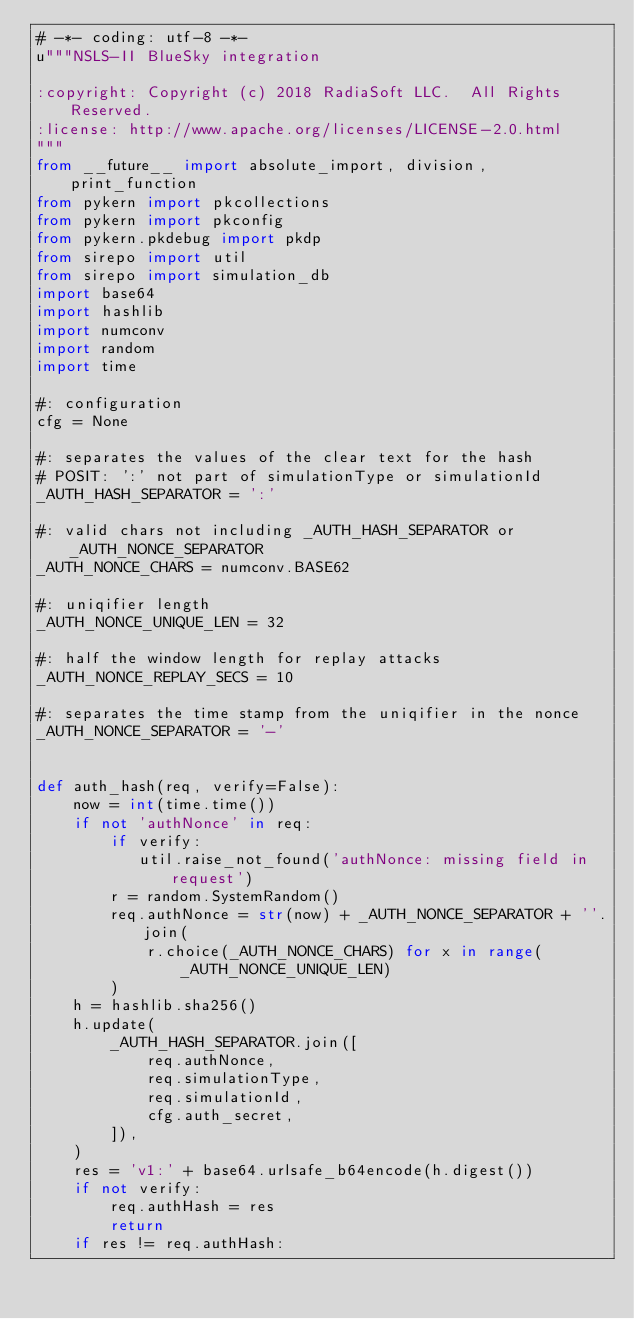Convert code to text. <code><loc_0><loc_0><loc_500><loc_500><_Python_># -*- coding: utf-8 -*-
u"""NSLS-II BlueSky integration

:copyright: Copyright (c) 2018 RadiaSoft LLC.  All Rights Reserved.
:license: http://www.apache.org/licenses/LICENSE-2.0.html
"""
from __future__ import absolute_import, division, print_function
from pykern import pkcollections
from pykern import pkconfig
from pykern.pkdebug import pkdp
from sirepo import util
from sirepo import simulation_db
import base64
import hashlib
import numconv
import random
import time

#: configuration
cfg = None

#: separates the values of the clear text for the hash
# POSIT: ':' not part of simulationType or simulationId
_AUTH_HASH_SEPARATOR = ':'

#: valid chars not including _AUTH_HASH_SEPARATOR or _AUTH_NONCE_SEPARATOR
_AUTH_NONCE_CHARS = numconv.BASE62

#: uniqifier length
_AUTH_NONCE_UNIQUE_LEN = 32

#: half the window length for replay attacks
_AUTH_NONCE_REPLAY_SECS = 10

#: separates the time stamp from the uniqifier in the nonce
_AUTH_NONCE_SEPARATOR = '-'


def auth_hash(req, verify=False):
    now = int(time.time())
    if not 'authNonce' in req:
        if verify:
           util.raise_not_found('authNonce: missing field in request')
        r = random.SystemRandom()
        req.authNonce = str(now) + _AUTH_NONCE_SEPARATOR + ''.join(
            r.choice(_AUTH_NONCE_CHARS) for x in range(_AUTH_NONCE_UNIQUE_LEN)
        )
    h = hashlib.sha256()
    h.update(
        _AUTH_HASH_SEPARATOR.join([
            req.authNonce,
            req.simulationType,
            req.simulationId,
            cfg.auth_secret,
        ]),
    )
    res = 'v1:' + base64.urlsafe_b64encode(h.digest())
    if not verify:
        req.authHash = res
        return
    if res != req.authHash:</code> 